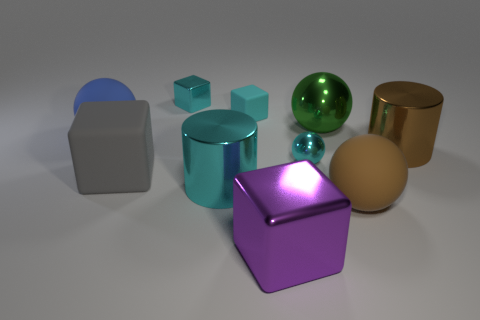Subtract 1 blocks. How many blocks are left? 3 Subtract all cylinders. How many objects are left? 8 Add 6 large brown rubber things. How many large brown rubber things are left? 7 Add 7 cyan metallic things. How many cyan metallic things exist? 10 Subtract 0 green cylinders. How many objects are left? 10 Subtract all large metallic balls. Subtract all small matte cubes. How many objects are left? 8 